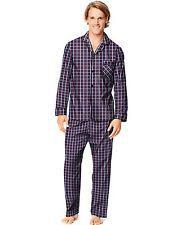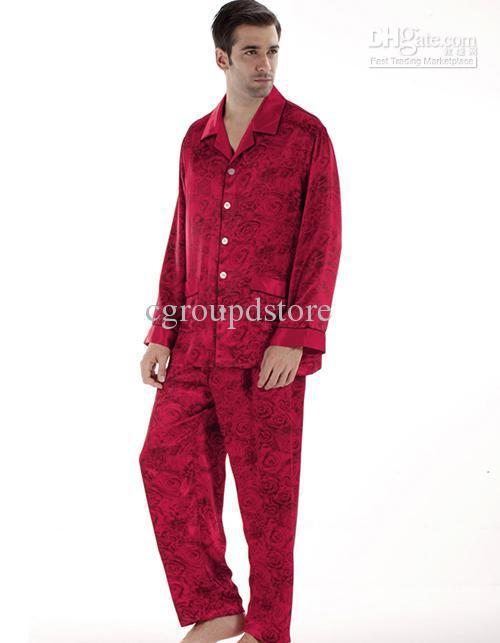The first image is the image on the left, the second image is the image on the right. Assess this claim about the two images: "in one of the images, a man is holding on to the front of his clothing with one hand". Correct or not? Answer yes or no. No. 